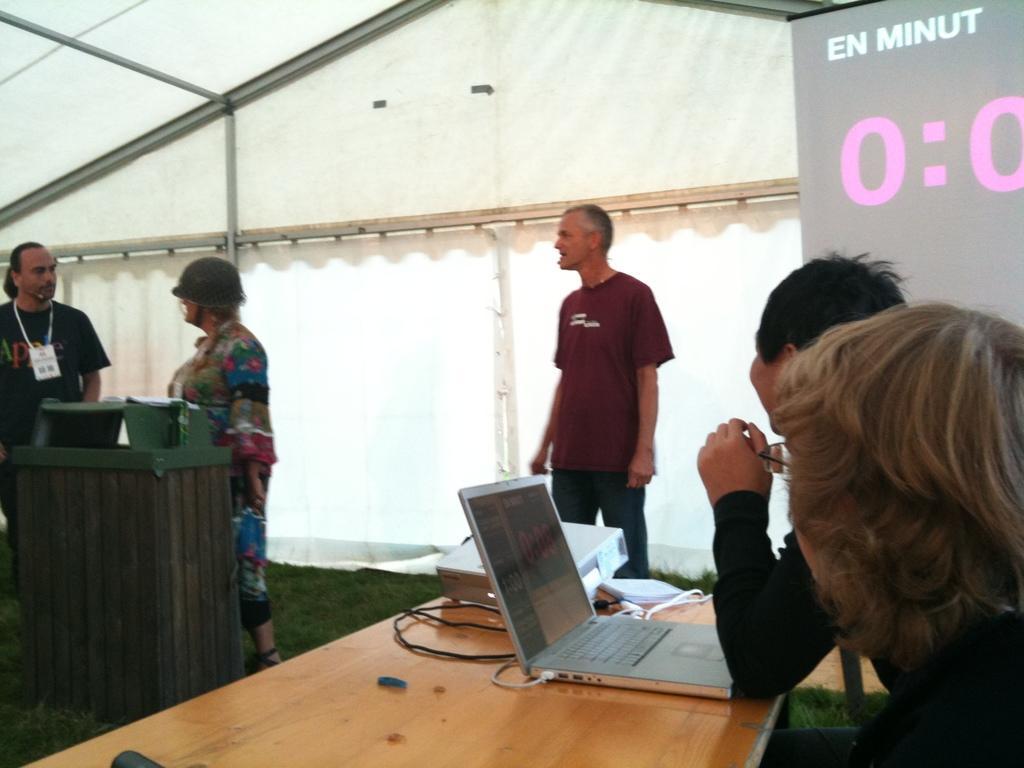In one or two sentences, can you explain what this image depicts? This picture shows few people are standing and few are seated on the chairs and we see a laptop and projector screen and projector on the table 